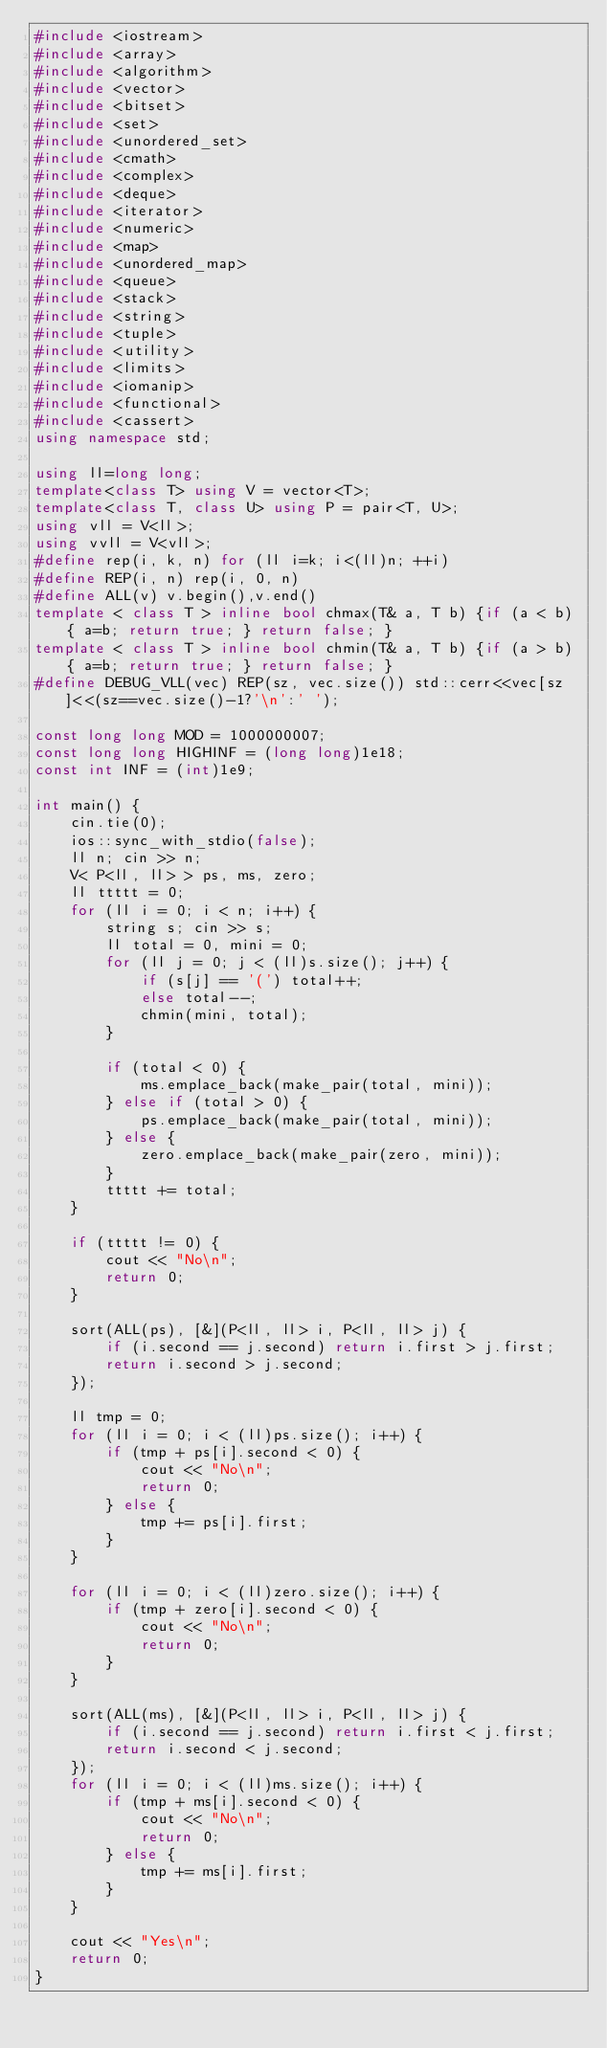<code> <loc_0><loc_0><loc_500><loc_500><_C++_>#include <iostream>
#include <array>
#include <algorithm>
#include <vector>
#include <bitset>
#include <set>
#include <unordered_set>
#include <cmath>
#include <complex>
#include <deque>
#include <iterator>
#include <numeric>
#include <map>
#include <unordered_map>
#include <queue>
#include <stack>
#include <string>
#include <tuple>
#include <utility>
#include <limits>
#include <iomanip>
#include <functional>
#include <cassert>
using namespace std;

using ll=long long;
template<class T> using V = vector<T>;
template<class T, class U> using P = pair<T, U>;
using vll = V<ll>;
using vvll = V<vll>;
#define rep(i, k, n) for (ll i=k; i<(ll)n; ++i)
#define REP(i, n) rep(i, 0, n)
#define ALL(v) v.begin(),v.end()
template < class T > inline bool chmax(T& a, T b) {if (a < b) { a=b; return true; } return false; }
template < class T > inline bool chmin(T& a, T b) {if (a > b) { a=b; return true; } return false; }
#define DEBUG_VLL(vec) REP(sz, vec.size()) std::cerr<<vec[sz]<<(sz==vec.size()-1?'\n':' ');

const long long MOD = 1000000007;
const long long HIGHINF = (long long)1e18;
const int INF = (int)1e9;

int main() {
    cin.tie(0);
    ios::sync_with_stdio(false);
    ll n; cin >> n;
    V< P<ll, ll> > ps, ms, zero;
    ll ttttt = 0;
    for (ll i = 0; i < n; i++) {
        string s; cin >> s;
        ll total = 0, mini = 0;
        for (ll j = 0; j < (ll)s.size(); j++) {
            if (s[j] == '(') total++;
            else total--;
            chmin(mini, total);
        }

        if (total < 0) {
            ms.emplace_back(make_pair(total, mini));
        } else if (total > 0) {
            ps.emplace_back(make_pair(total, mini));
        } else {
            zero.emplace_back(make_pair(zero, mini));
        }
        ttttt += total;
    }

    if (ttttt != 0) {
        cout << "No\n";
        return 0;
    }

    sort(ALL(ps), [&](P<ll, ll> i, P<ll, ll> j) {
        if (i.second == j.second) return i.first > j.first;
        return i.second > j.second;
    });

    ll tmp = 0;
    for (ll i = 0; i < (ll)ps.size(); i++) {
        if (tmp + ps[i].second < 0) {
            cout << "No\n";
            return 0;
        } else {
            tmp += ps[i].first;
        }
    }

    for (ll i = 0; i < (ll)zero.size(); i++) {
        if (tmp + zero[i].second < 0) {
            cout << "No\n";
            return 0;
        }
    }

    sort(ALL(ms), [&](P<ll, ll> i, P<ll, ll> j) {
        if (i.second == j.second) return i.first < j.first;
        return i.second < j.second;
    });
    for (ll i = 0; i < (ll)ms.size(); i++) {
        if (tmp + ms[i].second < 0) {
            cout << "No\n";
            return 0;
        } else {
            tmp += ms[i].first;
        }
    }

    cout << "Yes\n";
    return 0;
}
</code> 